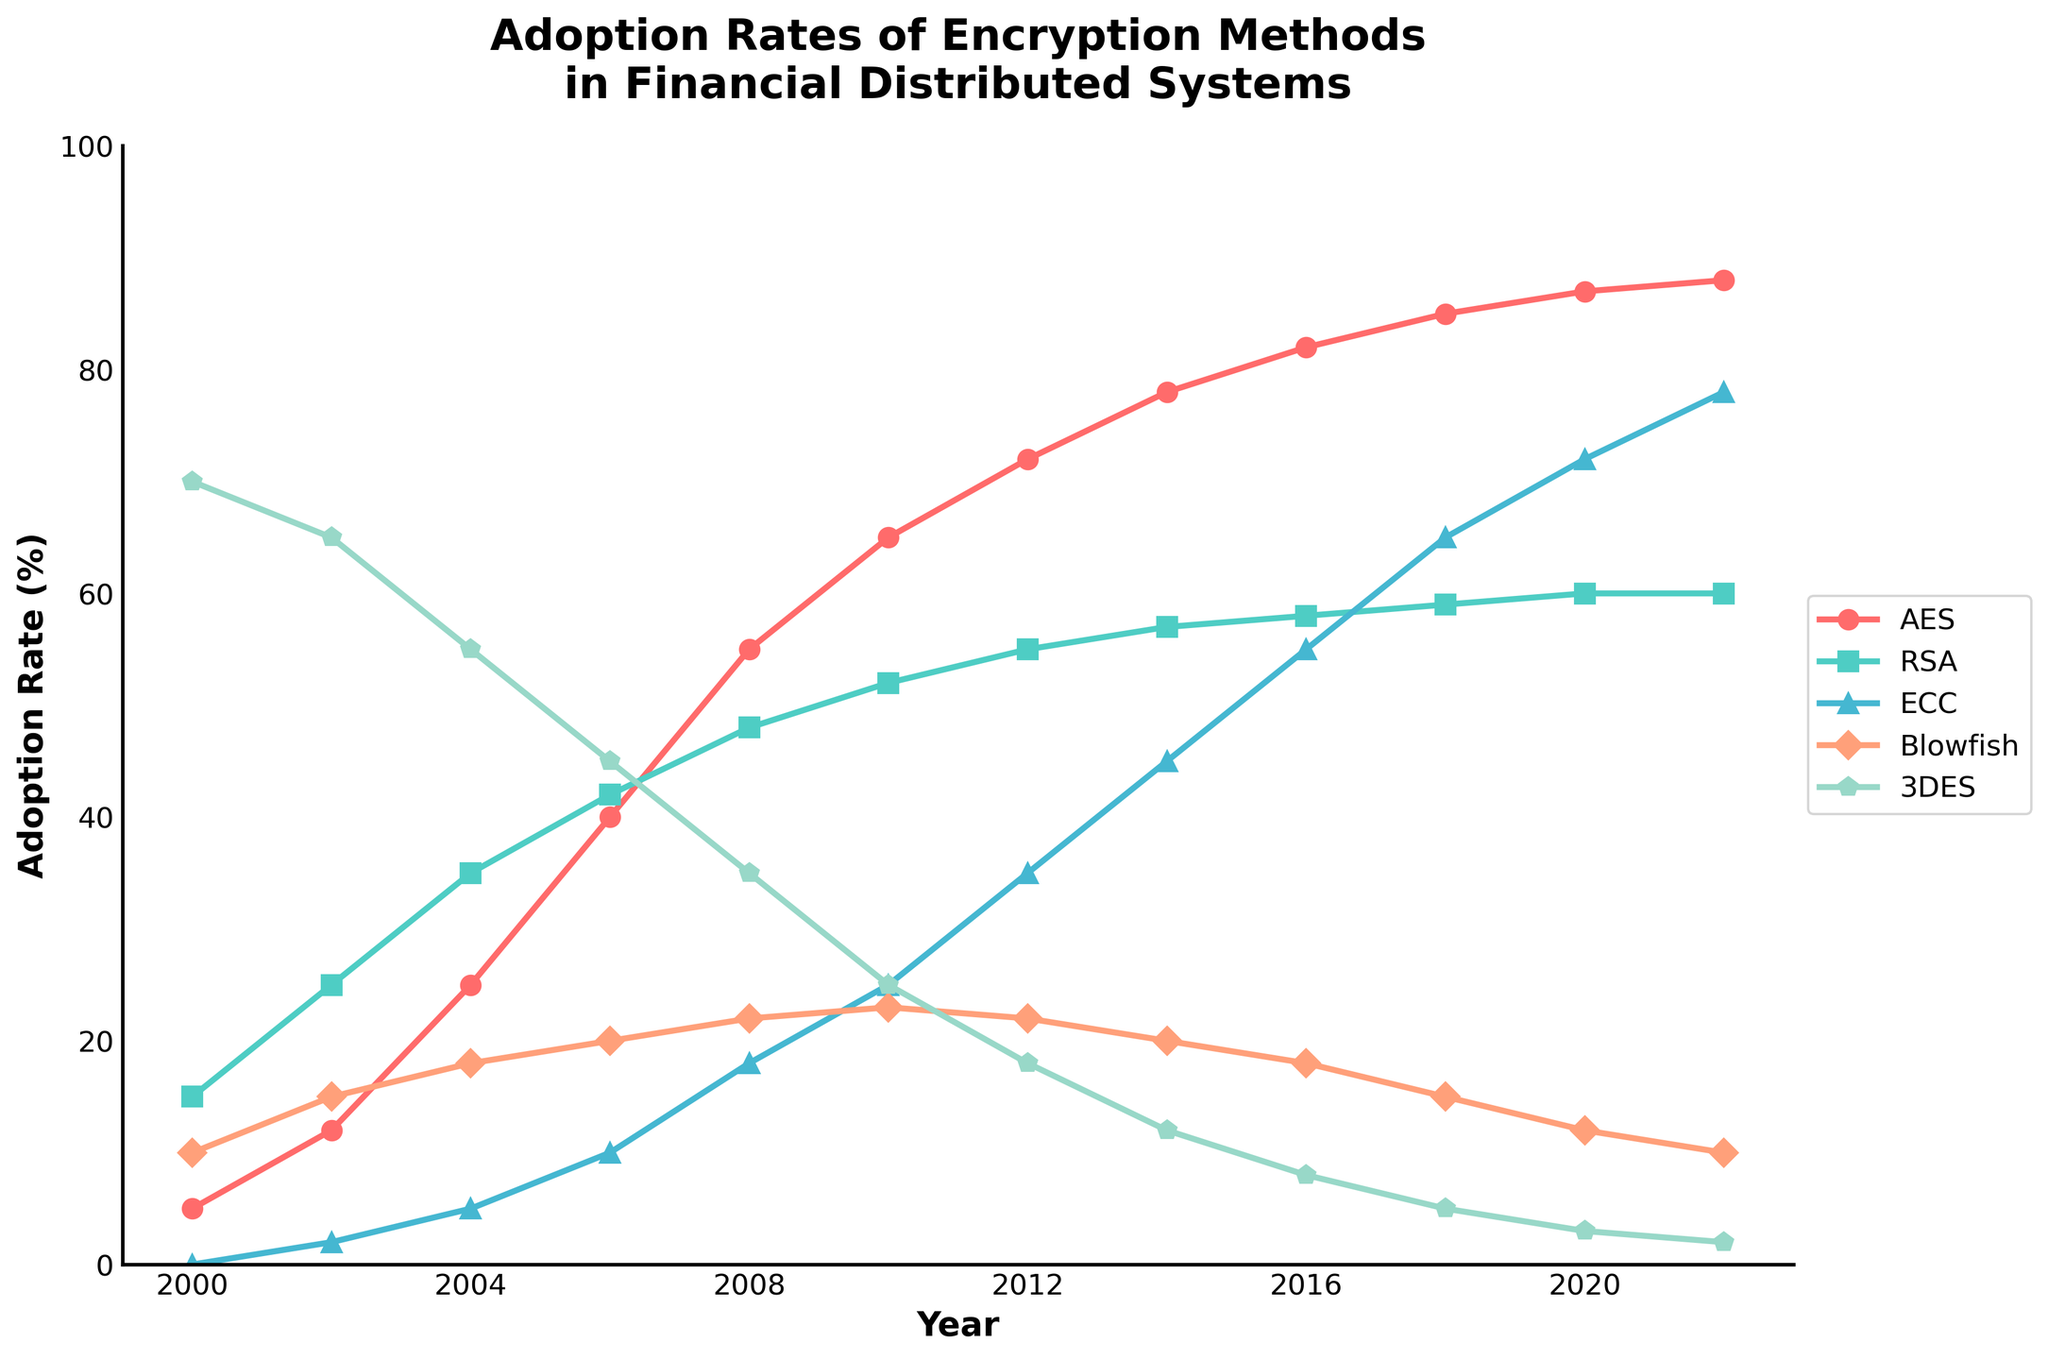What year did AES surpass Blowfish in adoption rate? First, find the points where the lines for AES and Blowfish intersect. Between 2004 and 2006, AES rises above Blowfish. Therefore, we look at the years within this range. From the figure, it can be inferred that in 2006, AES adoption rate surpasses Blowfish's.
Answer: 2006 By how much did the adoption rate of RSA change between 2000 and 2022? Identify the adoption rates of RSA in 2000 and 2022. In 2000, the RSA adoption rate is 15%, and in 2022, it is 60%. Calculate the difference: 60% - 15% = 45%.
Answer: 45% Which encryption method had the highest adoption rate in 2002? Compare the adoption rates of all the methods in the year 2002. The values are: AES (12%), RSA (25%), ECC (2%), Blowfish (15%), 3DES (65%). The highest adoption rate belongs to 3DES.
Answer: 3DES What is the average adoption rate of ECC over the years? Find the sum of the ECC adoption rates from the given years (0+2+5+10+18+25+35+45+55+65+72+78). Then, divide by the number of data points (12). Sum = 410, Average = 410 / 12 ≈ 34.17
Answer: 34.17% In which year was the drop in the adoption rate of 3DES most significant? Examine the chart to see the trend of 3DES. The most significant drop is visible between 2002 and 2004 (65% to 55%, a drop of 10%).
Answer: 2004 What is the difference in adoption rates between AES and ECC in 2012? Find the adoption rates of AES and ECC in 2012. AES is at 72%, and ECC is at 35%. Compute the difference: 72% - 35% = 37%.
Answer: 37% Which encryption method shows the most steady increase in adoption rate throughout the years? Visually observe the trend lines for all methods. AES shows a consistent and relatively straight upward trend compared to others, indicating a steady increase.
Answer: AES How does the adoption rate of Blowfish in 2018 compare to that in 2010? Look at the adoption rates for Blowfish in 2018 (15%) and 2010 (23%). Compare the two values to see that the adoption rate has decreased by 8%.
Answer: Decreased by 8% Which encryption method had the lowest adoption rate in 2020? Check the adoption rates of all methods in the year 2020. The values are: AES (87%), RSA (60%), ECC (72%), Blowfish (12%), 3DES (3%). The lowest adoption rate is for 3DES at 3%.
Answer: 3DES 